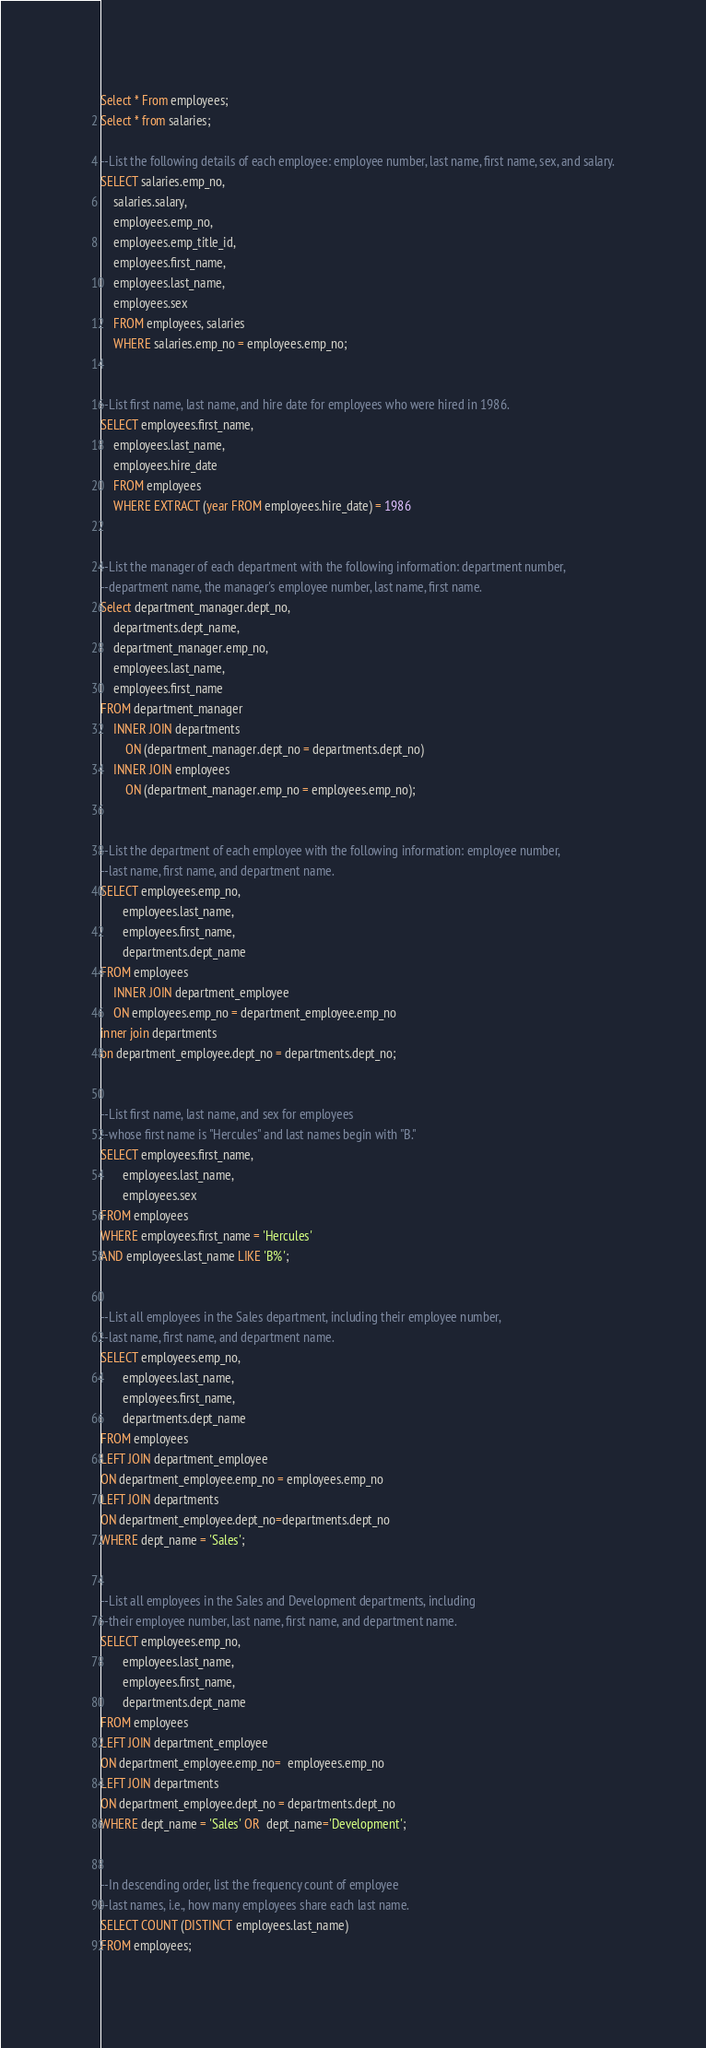Convert code to text. <code><loc_0><loc_0><loc_500><loc_500><_SQL_>Select * From employees;
Select * from salaries;

--List the following details of each employee: employee number, last name, first name, sex, and salary.
SELECT salaries.emp_no,
	salaries.salary,
	employees.emp_no,
	employees.emp_title_id,
	employees.first_name,
	employees.last_name,
	employees.sex
 	FROM employees, salaries
	WHERE salaries.emp_no = employees.emp_no;
	

--List first name, last name, and hire date for employees who were hired in 1986.
SELECT employees.first_name,
	employees.last_name,
	employees.hire_date
	FROM employees
	WHERE EXTRACT (year FROM employees.hire_date) = 1986


--List the manager of each department with the following information: department number, 
--department name, the manager's employee number, last name, first name.
Select department_manager.dept_no,
	departments.dept_name,
	department_manager.emp_no, 
	employees.last_name, 
	employees.first_name
FROM department_manager
	INNER JOIN departments 
		ON (department_manager.dept_no = departments.dept_no)
	INNER JOIN employees
		ON (department_manager.emp_no = employees.emp_no);
	
	
--List the department of each employee with the following information: employee number, 
--last name, first name, and department name.
SELECT employees.emp_no,
       employees.last_name,
       employees.first_name,
       departments.dept_name
FROM employees 
    INNER JOIN department_employee
    ON employees.emp_no = department_employee.emp_no
inner join departments
on department_employee.dept_no = departments.dept_no;


--List first name, last name, and sex for employees 
--whose first name is "Hercules" and last names begin with "B."
SELECT employees.first_name,
	   employees.last_name,
	   employees.sex
FROM employees
WHERE employees.first_name = 'Hercules' 
AND employees.last_name LIKE 'B%';


--List all employees in the Sales department, including their employee number,
--last name, first name, and department name.
SELECT employees.emp_no,
	   employees.last_name,
	   employees.first_name,
	   departments.dept_name
FROM employees
LEFT JOIN department_employee 
ON department_employee.emp_no = employees.emp_no
LEFT JOIN departments
ON department_employee.dept_no=departments.dept_no
WHERE dept_name = 'Sales';


--List all employees in the Sales and Development departments, including 
--their employee number, last name, first name, and department name.
SELECT employees.emp_no,
	   employees.last_name,
	   employees.first_name,
	   departments.dept_name
FROM employees
LEFT JOIN department_employee
ON department_employee.emp_no=  employees.emp_no
LEFT JOIN departments
ON department_employee.dept_no = departments.dept_no
WHERE dept_name = 'Sales' OR  dept_name='Development'; 


--In descending order, list the frequency count of employee 
--last names, i.e., how many employees share each last name.
SELECT COUNT (DISTINCT employees.last_name)
FROM employees;



</code> 